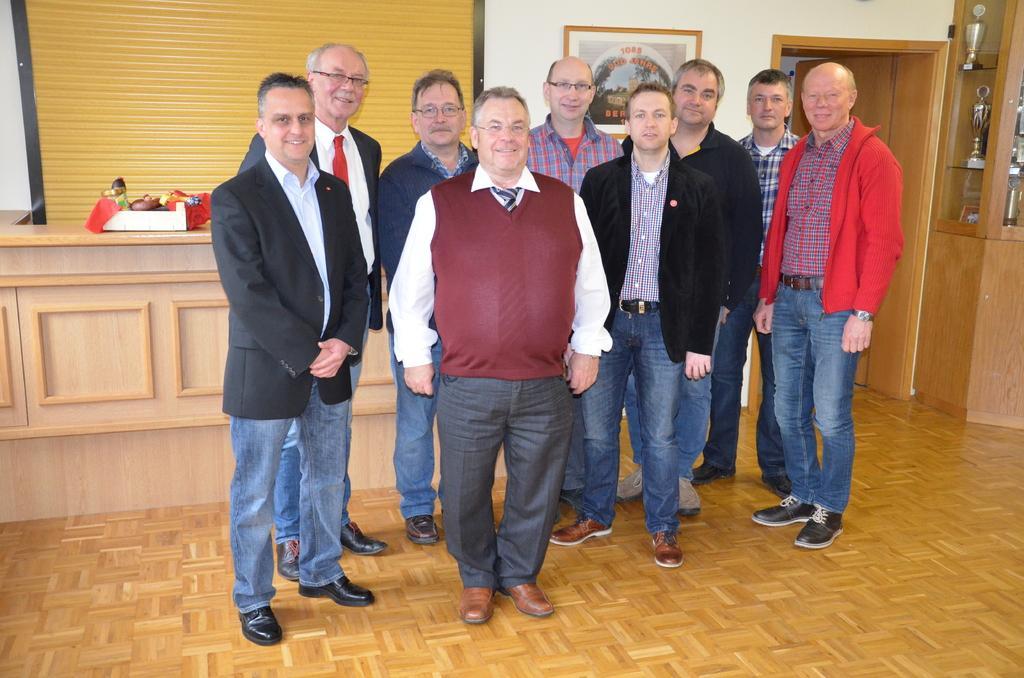Can you describe this image briefly? In this picture we can see the group of men, standing in the front and giving a pose to the camera. Behind there is a wall with hanging photo frame, wooden table and door. 